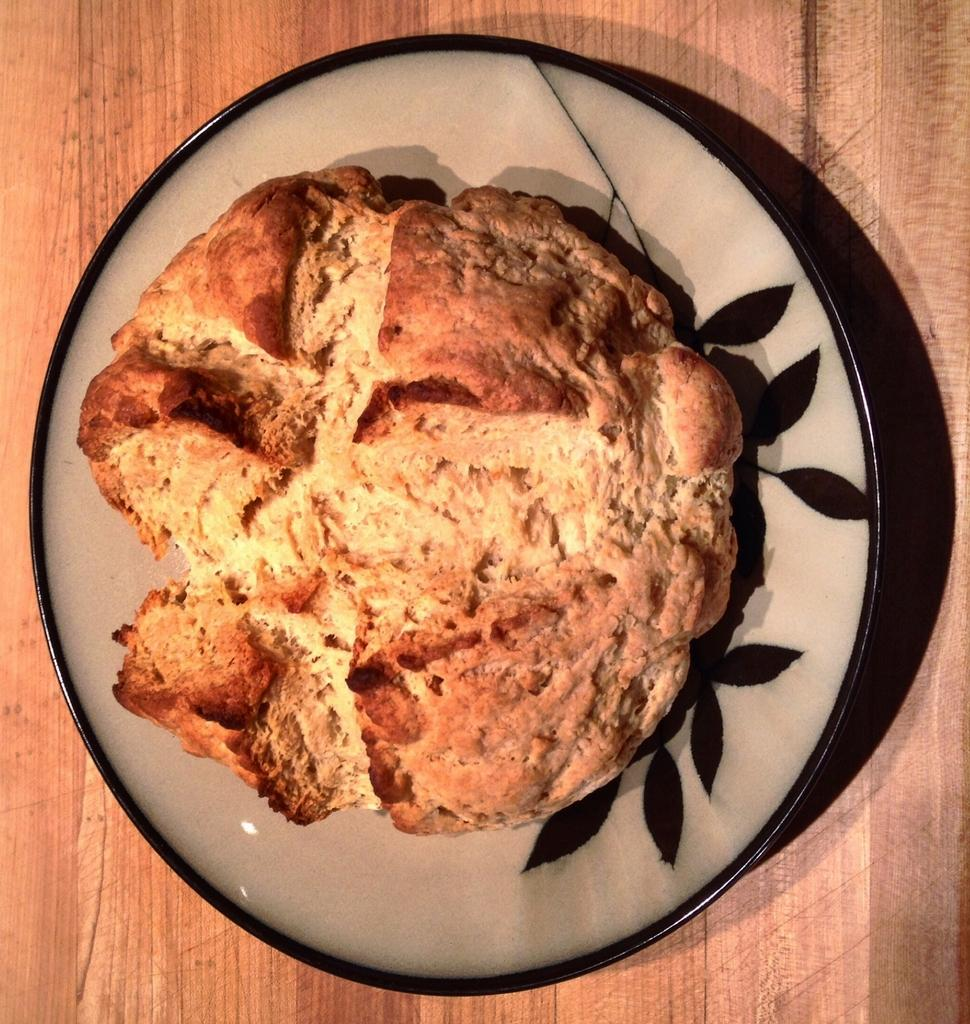What piece of furniture is present in the image? There is a table in the image. What is placed on the table? There is a plate with food on the table. What type of farm animals can be seen at the party in the image? There is no farm or party present in the image; it only features a table with a plate of food. 